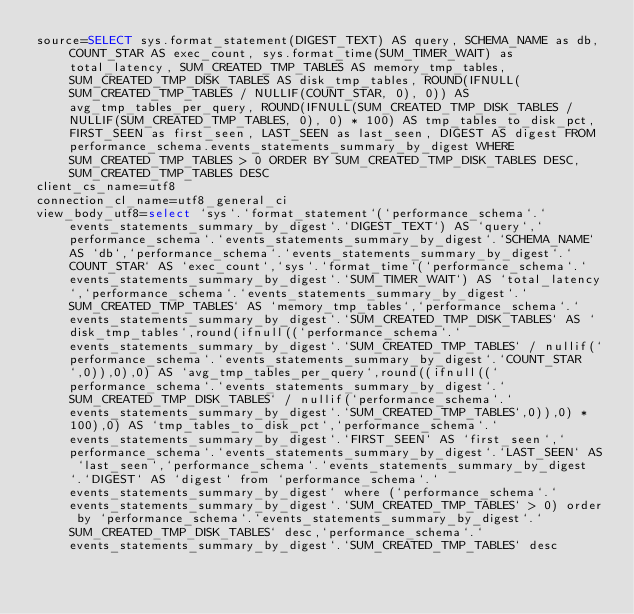<code> <loc_0><loc_0><loc_500><loc_500><_VisualBasic_>source=SELECT sys.format_statement(DIGEST_TEXT) AS query, SCHEMA_NAME as db, COUNT_STAR AS exec_count, sys.format_time(SUM_TIMER_WAIT) as total_latency, SUM_CREATED_TMP_TABLES AS memory_tmp_tables, SUM_CREATED_TMP_DISK_TABLES AS disk_tmp_tables, ROUND(IFNULL(SUM_CREATED_TMP_TABLES / NULLIF(COUNT_STAR, 0), 0)) AS avg_tmp_tables_per_query, ROUND(IFNULL(SUM_CREATED_TMP_DISK_TABLES / NULLIF(SUM_CREATED_TMP_TABLES, 0), 0) * 100) AS tmp_tables_to_disk_pct, FIRST_SEEN as first_seen, LAST_SEEN as last_seen, DIGEST AS digest FROM performance_schema.events_statements_summary_by_digest WHERE SUM_CREATED_TMP_TABLES > 0 ORDER BY SUM_CREATED_TMP_DISK_TABLES DESC, SUM_CREATED_TMP_TABLES DESC
client_cs_name=utf8
connection_cl_name=utf8_general_ci
view_body_utf8=select `sys`.`format_statement`(`performance_schema`.`events_statements_summary_by_digest`.`DIGEST_TEXT`) AS `query`,`performance_schema`.`events_statements_summary_by_digest`.`SCHEMA_NAME` AS `db`,`performance_schema`.`events_statements_summary_by_digest`.`COUNT_STAR` AS `exec_count`,`sys`.`format_time`(`performance_schema`.`events_statements_summary_by_digest`.`SUM_TIMER_WAIT`) AS `total_latency`,`performance_schema`.`events_statements_summary_by_digest`.`SUM_CREATED_TMP_TABLES` AS `memory_tmp_tables`,`performance_schema`.`events_statements_summary_by_digest`.`SUM_CREATED_TMP_DISK_TABLES` AS `disk_tmp_tables`,round(ifnull((`performance_schema`.`events_statements_summary_by_digest`.`SUM_CREATED_TMP_TABLES` / nullif(`performance_schema`.`events_statements_summary_by_digest`.`COUNT_STAR`,0)),0),0) AS `avg_tmp_tables_per_query`,round((ifnull((`performance_schema`.`events_statements_summary_by_digest`.`SUM_CREATED_TMP_DISK_TABLES` / nullif(`performance_schema`.`events_statements_summary_by_digest`.`SUM_CREATED_TMP_TABLES`,0)),0) * 100),0) AS `tmp_tables_to_disk_pct`,`performance_schema`.`events_statements_summary_by_digest`.`FIRST_SEEN` AS `first_seen`,`performance_schema`.`events_statements_summary_by_digest`.`LAST_SEEN` AS `last_seen`,`performance_schema`.`events_statements_summary_by_digest`.`DIGEST` AS `digest` from `performance_schema`.`events_statements_summary_by_digest` where (`performance_schema`.`events_statements_summary_by_digest`.`SUM_CREATED_TMP_TABLES` > 0) order by `performance_schema`.`events_statements_summary_by_digest`.`SUM_CREATED_TMP_DISK_TABLES` desc,`performance_schema`.`events_statements_summary_by_digest`.`SUM_CREATED_TMP_TABLES` desc
</code> 